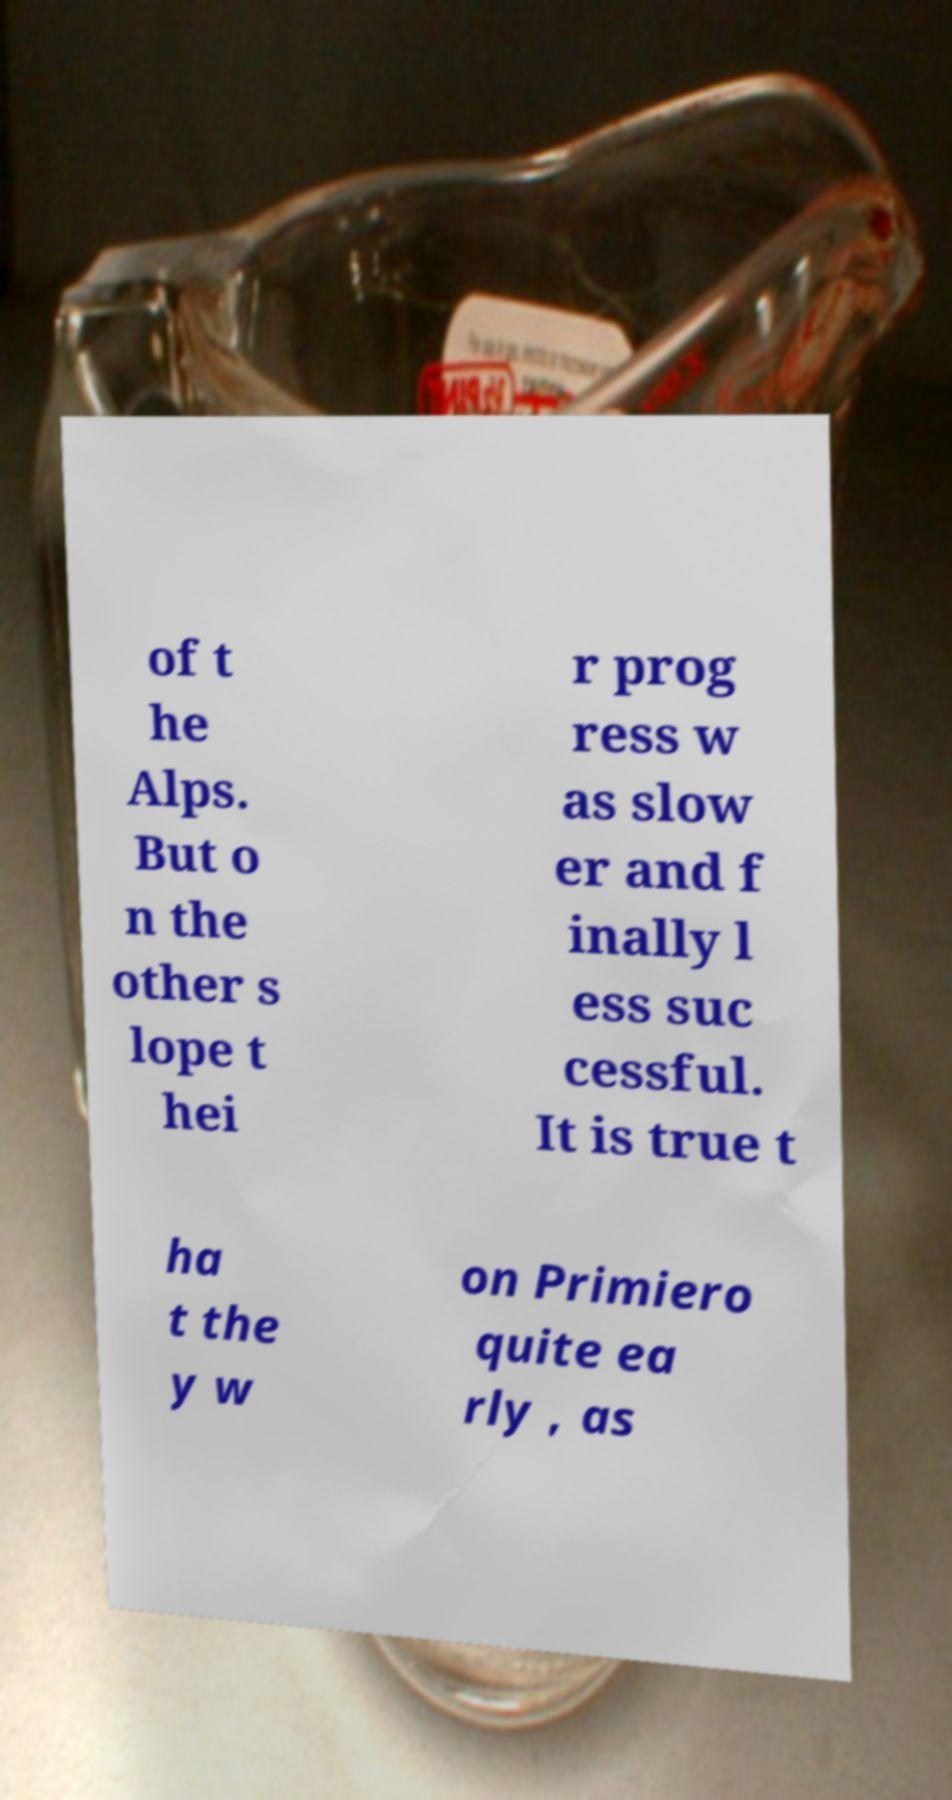Please read and relay the text visible in this image. What does it say? of t he Alps. But o n the other s lope t hei r prog ress w as slow er and f inally l ess suc cessful. It is true t ha t the y w on Primiero quite ea rly , as 